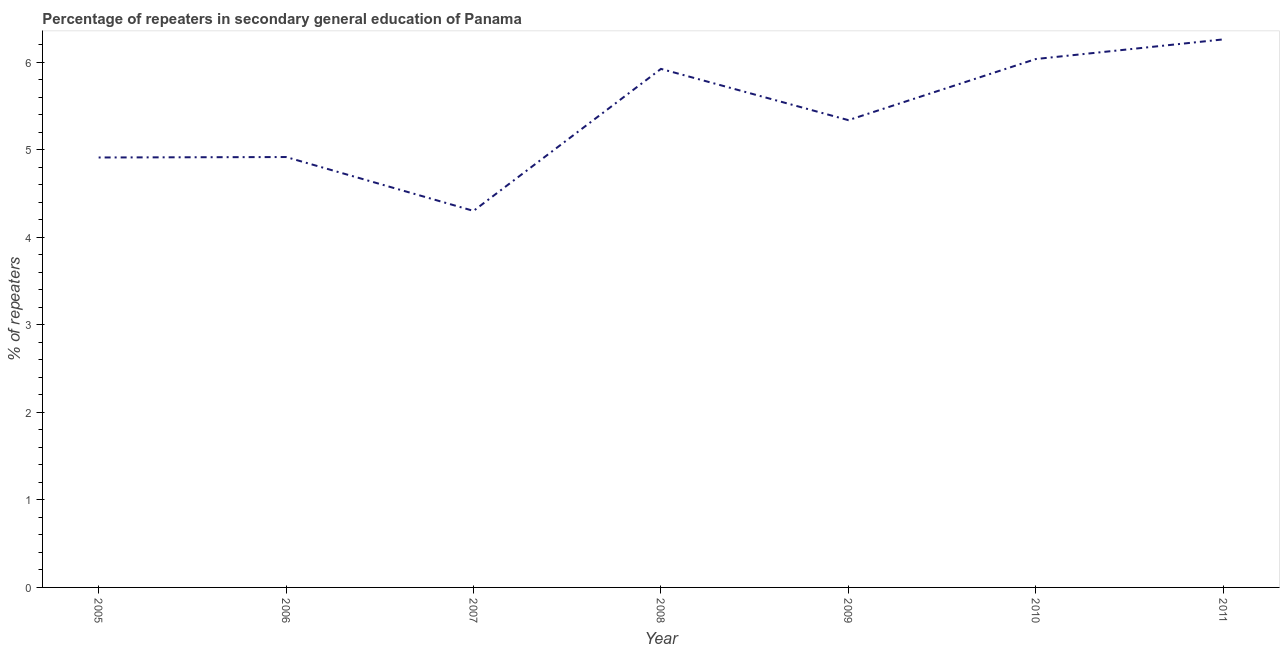What is the percentage of repeaters in 2010?
Your answer should be compact. 6.04. Across all years, what is the maximum percentage of repeaters?
Offer a very short reply. 6.26. Across all years, what is the minimum percentage of repeaters?
Your answer should be compact. 4.3. In which year was the percentage of repeaters maximum?
Offer a very short reply. 2011. In which year was the percentage of repeaters minimum?
Your answer should be very brief. 2007. What is the sum of the percentage of repeaters?
Offer a terse response. 37.69. What is the difference between the percentage of repeaters in 2006 and 2007?
Your answer should be compact. 0.62. What is the average percentage of repeaters per year?
Make the answer very short. 5.38. What is the median percentage of repeaters?
Make the answer very short. 5.34. In how many years, is the percentage of repeaters greater than 1.6 %?
Offer a very short reply. 7. Do a majority of the years between 2010 and 2011 (inclusive) have percentage of repeaters greater than 0.2 %?
Provide a succinct answer. Yes. What is the ratio of the percentage of repeaters in 2005 to that in 2008?
Your answer should be compact. 0.83. What is the difference between the highest and the second highest percentage of repeaters?
Give a very brief answer. 0.22. Is the sum of the percentage of repeaters in 2006 and 2009 greater than the maximum percentage of repeaters across all years?
Your answer should be compact. Yes. What is the difference between the highest and the lowest percentage of repeaters?
Your answer should be very brief. 1.96. How many years are there in the graph?
Your response must be concise. 7. What is the title of the graph?
Your response must be concise. Percentage of repeaters in secondary general education of Panama. What is the label or title of the X-axis?
Offer a terse response. Year. What is the label or title of the Y-axis?
Make the answer very short. % of repeaters. What is the % of repeaters in 2005?
Provide a short and direct response. 4.91. What is the % of repeaters in 2006?
Keep it short and to the point. 4.92. What is the % of repeaters in 2007?
Your answer should be very brief. 4.3. What is the % of repeaters of 2008?
Your response must be concise. 5.92. What is the % of repeaters in 2009?
Offer a terse response. 5.34. What is the % of repeaters in 2010?
Ensure brevity in your answer.  6.04. What is the % of repeaters of 2011?
Ensure brevity in your answer.  6.26. What is the difference between the % of repeaters in 2005 and 2006?
Provide a succinct answer. -0.01. What is the difference between the % of repeaters in 2005 and 2007?
Make the answer very short. 0.61. What is the difference between the % of repeaters in 2005 and 2008?
Provide a succinct answer. -1.01. What is the difference between the % of repeaters in 2005 and 2009?
Offer a terse response. -0.43. What is the difference between the % of repeaters in 2005 and 2010?
Give a very brief answer. -1.12. What is the difference between the % of repeaters in 2005 and 2011?
Give a very brief answer. -1.35. What is the difference between the % of repeaters in 2006 and 2007?
Your answer should be very brief. 0.62. What is the difference between the % of repeaters in 2006 and 2008?
Ensure brevity in your answer.  -1.01. What is the difference between the % of repeaters in 2006 and 2009?
Provide a short and direct response. -0.42. What is the difference between the % of repeaters in 2006 and 2010?
Ensure brevity in your answer.  -1.12. What is the difference between the % of repeaters in 2006 and 2011?
Provide a short and direct response. -1.34. What is the difference between the % of repeaters in 2007 and 2008?
Offer a terse response. -1.62. What is the difference between the % of repeaters in 2007 and 2009?
Your answer should be very brief. -1.04. What is the difference between the % of repeaters in 2007 and 2010?
Provide a succinct answer. -1.73. What is the difference between the % of repeaters in 2007 and 2011?
Provide a short and direct response. -1.96. What is the difference between the % of repeaters in 2008 and 2009?
Offer a very short reply. 0.59. What is the difference between the % of repeaters in 2008 and 2010?
Ensure brevity in your answer.  -0.11. What is the difference between the % of repeaters in 2008 and 2011?
Your response must be concise. -0.34. What is the difference between the % of repeaters in 2009 and 2010?
Provide a short and direct response. -0.7. What is the difference between the % of repeaters in 2009 and 2011?
Keep it short and to the point. -0.92. What is the difference between the % of repeaters in 2010 and 2011?
Make the answer very short. -0.22. What is the ratio of the % of repeaters in 2005 to that in 2006?
Make the answer very short. 1. What is the ratio of the % of repeaters in 2005 to that in 2007?
Make the answer very short. 1.14. What is the ratio of the % of repeaters in 2005 to that in 2008?
Your response must be concise. 0.83. What is the ratio of the % of repeaters in 2005 to that in 2010?
Offer a very short reply. 0.81. What is the ratio of the % of repeaters in 2005 to that in 2011?
Keep it short and to the point. 0.79. What is the ratio of the % of repeaters in 2006 to that in 2007?
Give a very brief answer. 1.14. What is the ratio of the % of repeaters in 2006 to that in 2008?
Ensure brevity in your answer.  0.83. What is the ratio of the % of repeaters in 2006 to that in 2009?
Offer a very short reply. 0.92. What is the ratio of the % of repeaters in 2006 to that in 2010?
Ensure brevity in your answer.  0.81. What is the ratio of the % of repeaters in 2006 to that in 2011?
Provide a short and direct response. 0.79. What is the ratio of the % of repeaters in 2007 to that in 2008?
Give a very brief answer. 0.73. What is the ratio of the % of repeaters in 2007 to that in 2009?
Ensure brevity in your answer.  0.81. What is the ratio of the % of repeaters in 2007 to that in 2010?
Offer a very short reply. 0.71. What is the ratio of the % of repeaters in 2007 to that in 2011?
Your answer should be very brief. 0.69. What is the ratio of the % of repeaters in 2008 to that in 2009?
Your answer should be very brief. 1.11. What is the ratio of the % of repeaters in 2008 to that in 2010?
Ensure brevity in your answer.  0.98. What is the ratio of the % of repeaters in 2008 to that in 2011?
Offer a very short reply. 0.95. What is the ratio of the % of repeaters in 2009 to that in 2010?
Offer a very short reply. 0.88. What is the ratio of the % of repeaters in 2009 to that in 2011?
Your answer should be compact. 0.85. What is the ratio of the % of repeaters in 2010 to that in 2011?
Keep it short and to the point. 0.96. 